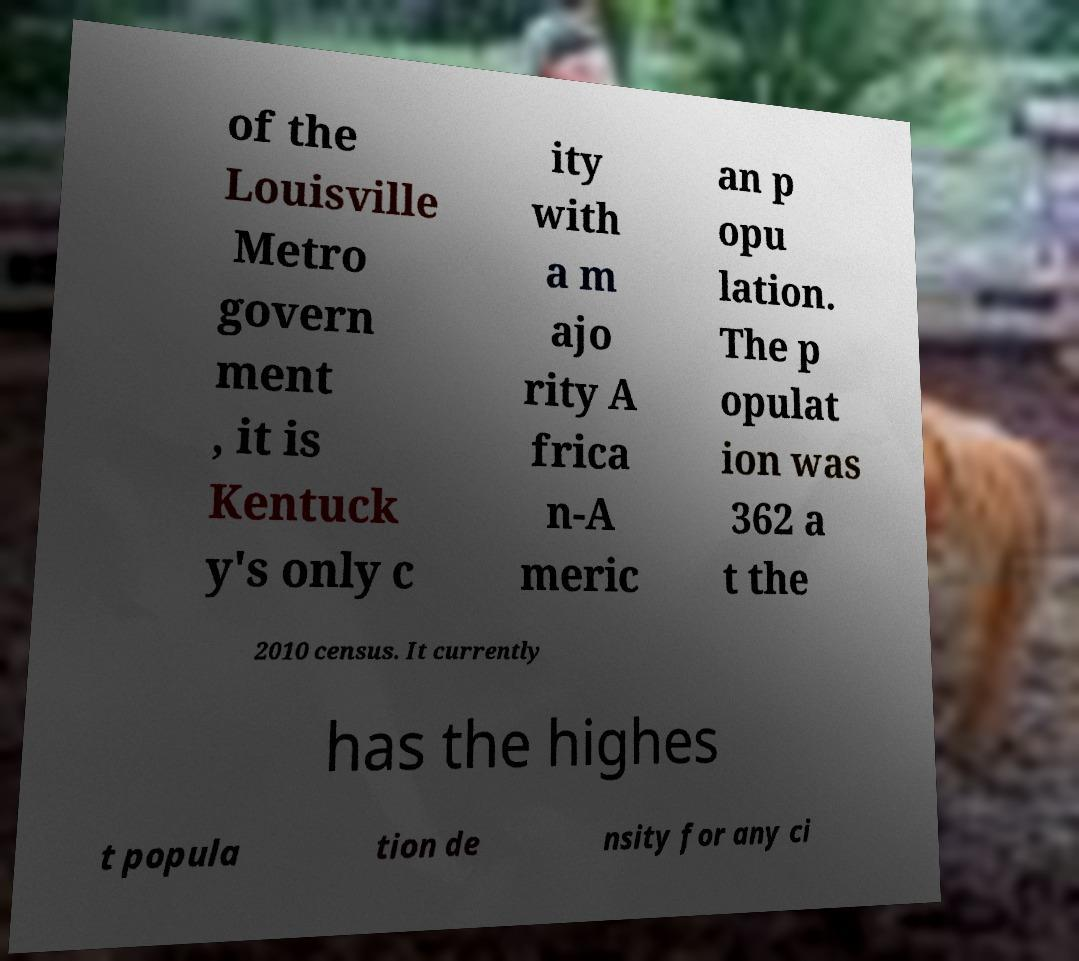There's text embedded in this image that I need extracted. Can you transcribe it verbatim? of the Louisville Metro govern ment , it is Kentuck y's only c ity with a m ajo rity A frica n-A meric an p opu lation. The p opulat ion was 362 a t the 2010 census. It currently has the highes t popula tion de nsity for any ci 